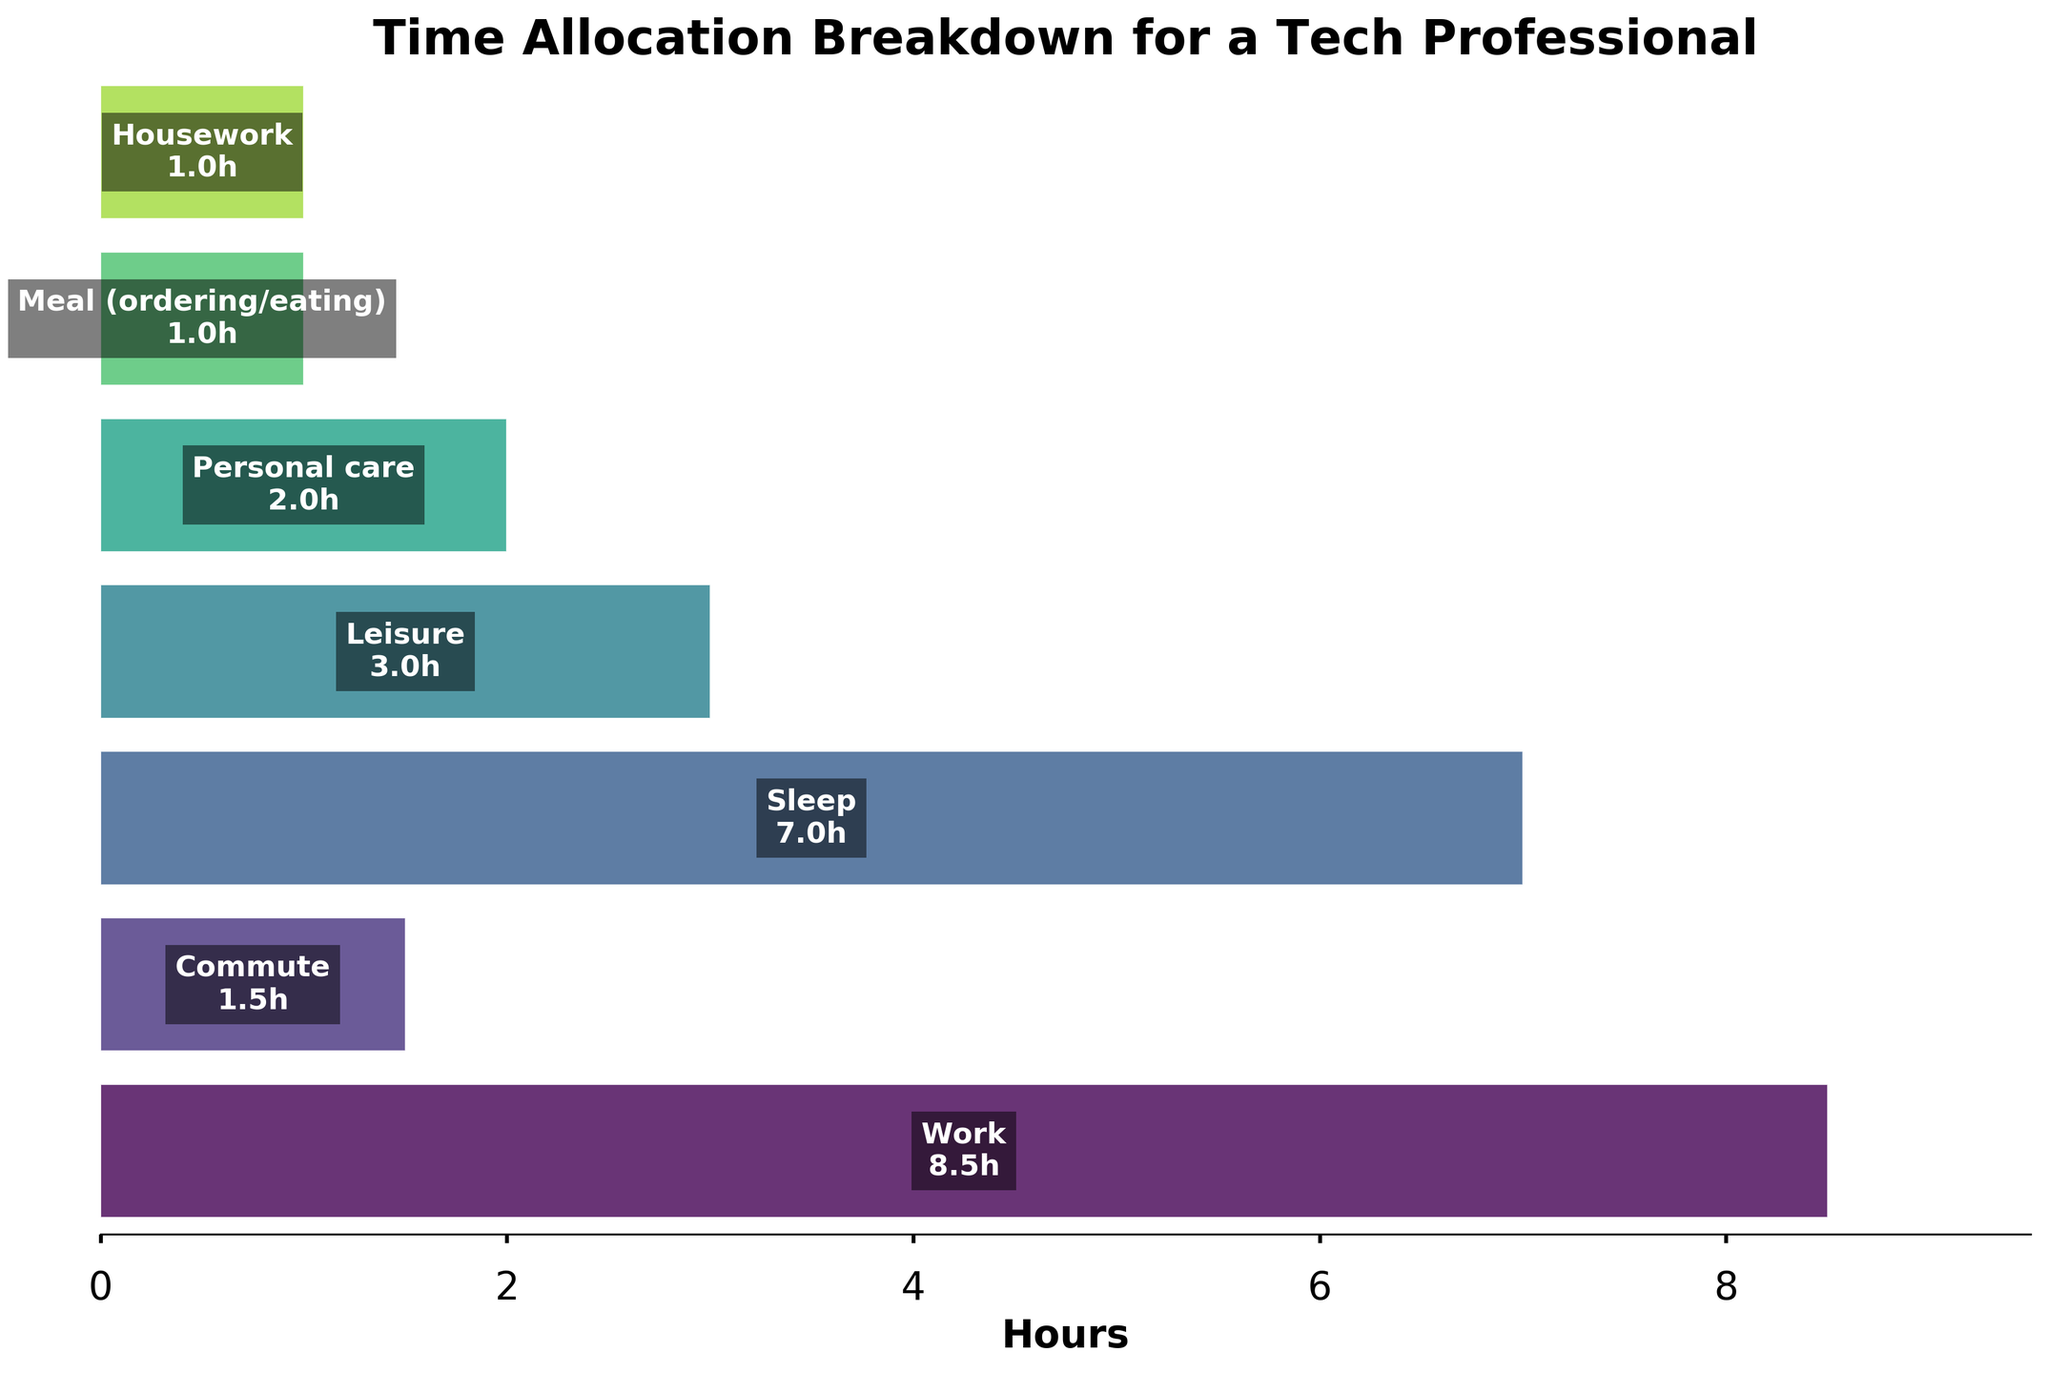What is the title of the chart? The title of the chart is usually found at the top of the figure and summarises the main topic of the visualization.
Answer: Time Allocation Breakdown for a Tech Professional How many hours are allocated to sleep? To find the hours allocated to sleep, locate the segment labeled "Sleep" in the figure. The number of hours is written inside the segment.
Answer: 7 hours Which activity takes up the most time in this typical workday? Identify the segment with the largest width in the funnel chart, indicating the activity that takes up the most hours.
Answer: Work What is the total number of hours accounted for across all activities? Sum up the hours spent on each activity mentioned in the funnel chart: Work (8.5), Commute (1.5), Sleep (7), Leisure (3), Personal care (2), Meal (ordering/eating) (1), Housework (1). Thus, 8.5 + 1.5 + 7 + 3 + 2 + 1 + 1 = 24.
Answer: 24 hours How many hours more are spent commuting compared to housework? Subtract the number of hours spent on housework from the hours spent commuting. Commute is 1.5 hours, and housework is 1 hour. Thus, 1.5 - 1 = 0.5.
Answer: 0.5 hours Which activity is allocated exactly 2 hours? Locate the segment that represents 2 hours in the figure. Only one activity will have this allocation.
Answer: Personal care What is the average number of hours spent on Leisure and Personal care combined? Find the total hours for Leisure and Personal care, then divide by the number of activities. Leisure is 3 hours, Personal care is 2 hours. Thus, (3 + 2) / 2 = 2.5 hours.
Answer: 2.5 hours What is the difference in hours spent on Work and Sleep? Subtract the hours spent on Sleep from the hours spent on Work. Work is 8.5 hours, Sleep is 7 hours. Thus, 8.5 - 7 = 1.5 hours.
Answer: 1.5 hours Which activity has the least amount of time allocated to it? Identify the segment with the smallest width in the funnel chart, indicating the activity with the fewest hours.
Answer: Meal (ordering/eating) & Housework 